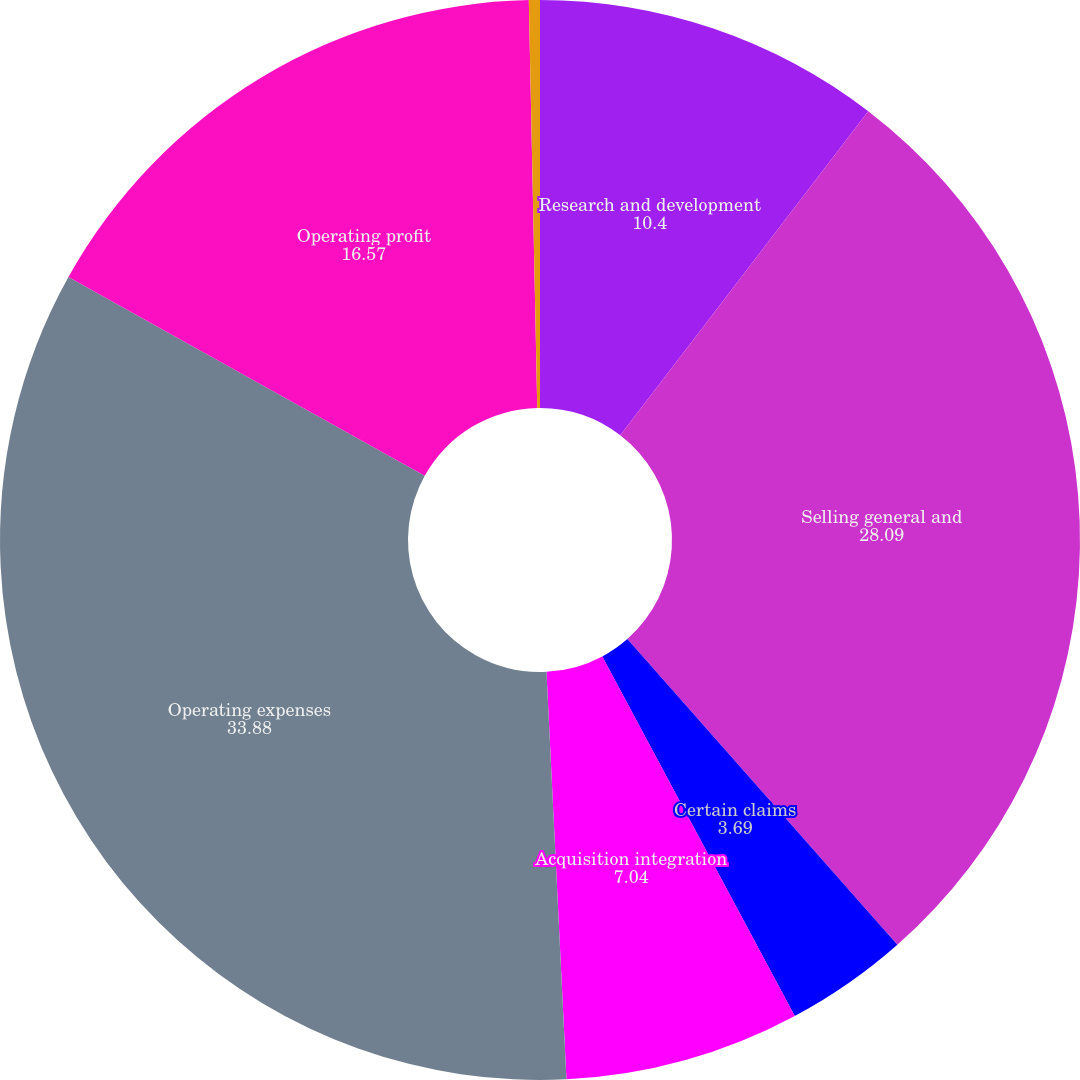Convert chart. <chart><loc_0><loc_0><loc_500><loc_500><pie_chart><fcel>Research and development<fcel>Selling general and<fcel>Certain claims<fcel>Acquisition integration<fcel>Operating expenses<fcel>Operating profit<fcel>Interest and other income<nl><fcel>10.4%<fcel>28.09%<fcel>3.69%<fcel>7.04%<fcel>33.88%<fcel>16.57%<fcel>0.33%<nl></chart> 